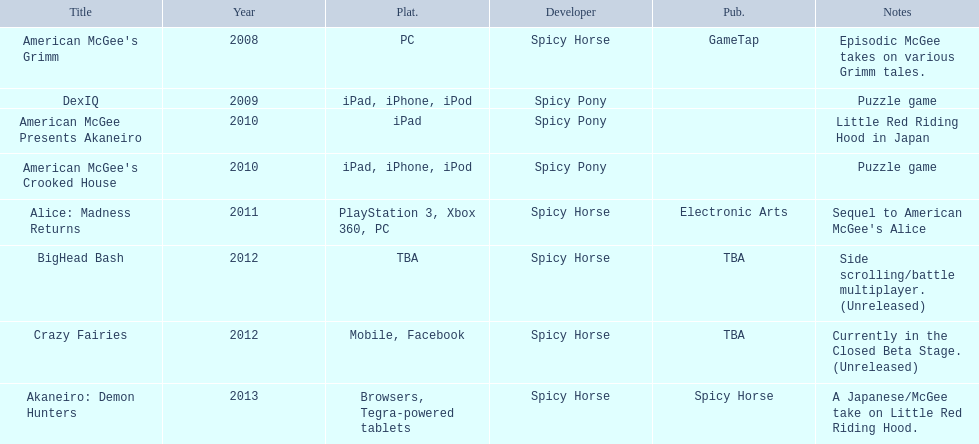What spicy horse titles are listed? American McGee's Grimm, DexIQ, American McGee Presents Akaneiro, American McGee's Crooked House, Alice: Madness Returns, BigHead Bash, Crazy Fairies, Akaneiro: Demon Hunters. Which of these can be used on ipad? DexIQ, American McGee Presents Akaneiro, American McGee's Crooked House. Which left cannot also be used on iphone or ipod? American McGee Presents Akaneiro. 